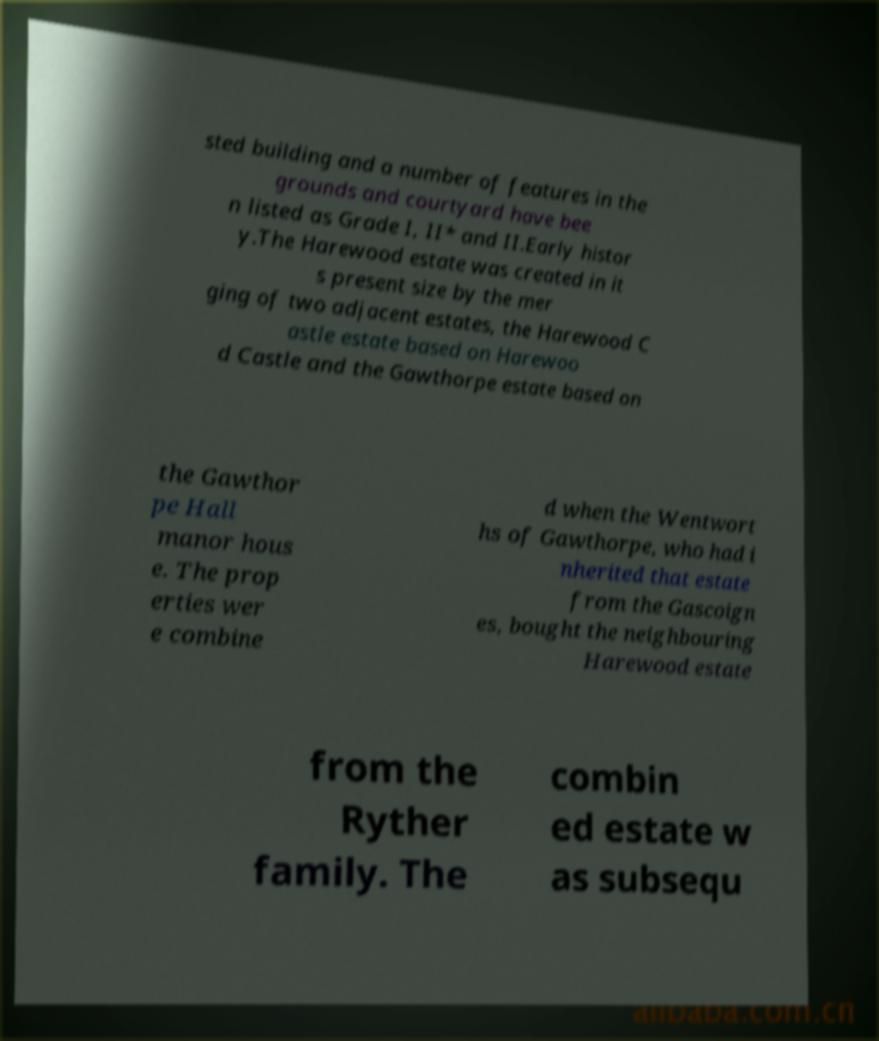For documentation purposes, I need the text within this image transcribed. Could you provide that? sted building and a number of features in the grounds and courtyard have bee n listed as Grade I, II* and II.Early histor y.The Harewood estate was created in it s present size by the mer ging of two adjacent estates, the Harewood C astle estate based on Harewoo d Castle and the Gawthorpe estate based on the Gawthor pe Hall manor hous e. The prop erties wer e combine d when the Wentwort hs of Gawthorpe, who had i nherited that estate from the Gascoign es, bought the neighbouring Harewood estate from the Ryther family. The combin ed estate w as subsequ 